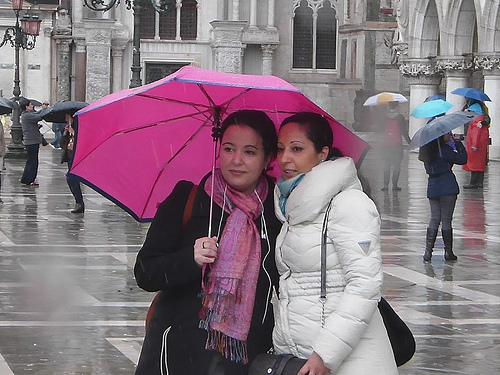Question: why are the people carrying umbrellas in the picture?
Choices:
A. To look nice.
B. To avoid getting wet in the rain.
C. To carry groceries with it.
D. To make others look bad.
Answer with the letter. Answer: B Question: what kind of weather is this?
Choices:
A. Rain.
B. Sunny.
C. Clear.
D. Foggy.
Answer with the letter. Answer: A Question: how many umbrellas are in the photo?
Choices:
A. One.
B. Two.
C. Three.
D. Nine.
Answer with the letter. Answer: D Question: what are all the people walking on?
Choices:
A. The beach.
B. In a car park.
C. Sidewalk.
D. On the street.
Answer with the letter. Answer: C Question: how many pink umbrellas are in the scene?
Choices:
A. Two.
B. Three.
C. One.
D. Four.
Answer with the letter. Answer: C Question: where is this taking place?
Choices:
A. Outside a shopping center.
B. At the park.
C. On a street during a parade.
D. In a public square.
Answer with the letter. Answer: D 